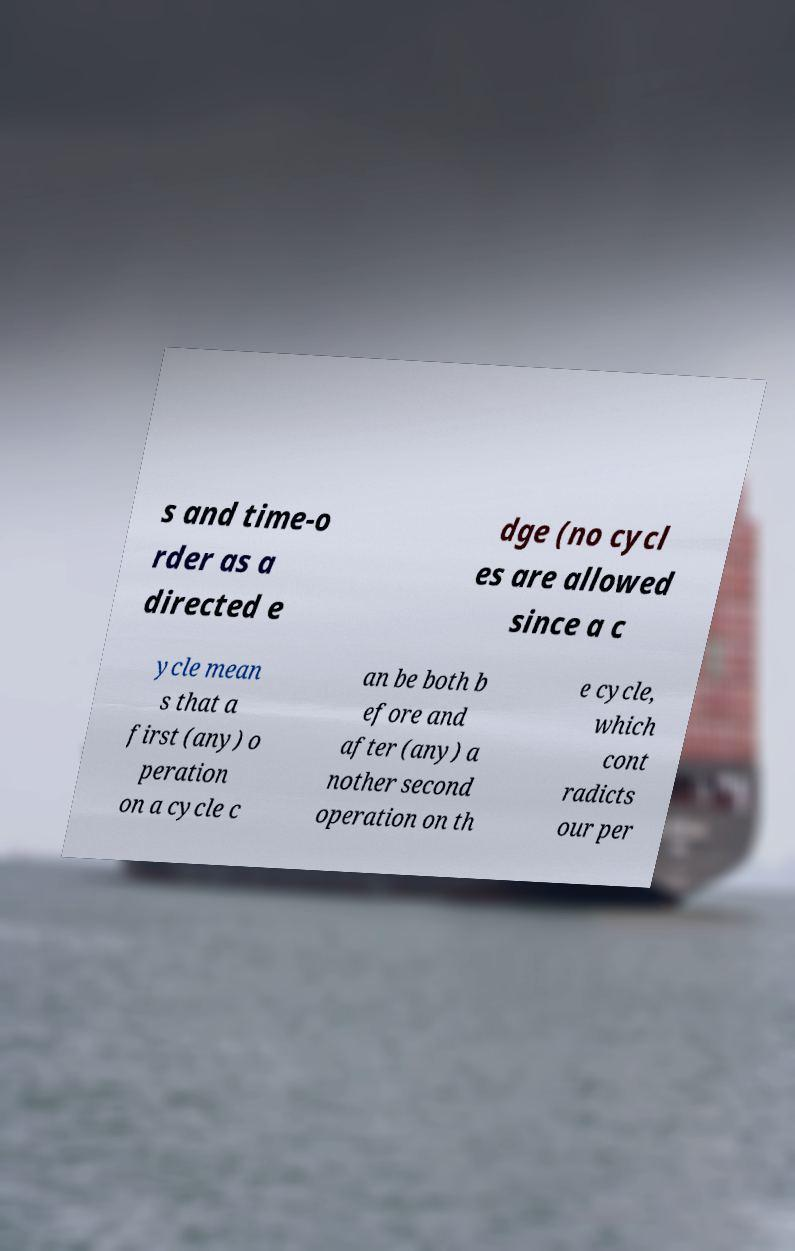Please identify and transcribe the text found in this image. s and time-o rder as a directed e dge (no cycl es are allowed since a c ycle mean s that a first (any) o peration on a cycle c an be both b efore and after (any) a nother second operation on th e cycle, which cont radicts our per 